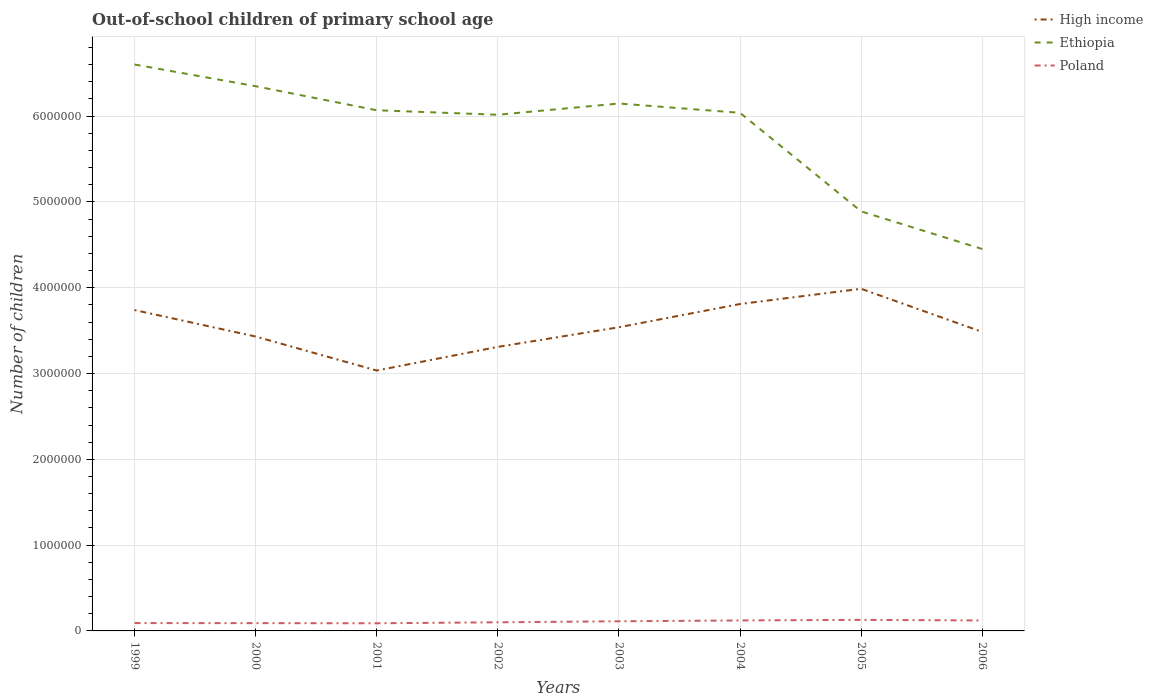How many different coloured lines are there?
Keep it short and to the point. 3. Across all years, what is the maximum number of out-of-school children in High income?
Offer a very short reply. 3.03e+06. In which year was the number of out-of-school children in Poland maximum?
Offer a terse response. 2001. What is the total number of out-of-school children in High income in the graph?
Ensure brevity in your answer.  4.29e+05. What is the difference between the highest and the second highest number of out-of-school children in Ethiopia?
Keep it short and to the point. 2.15e+06. What is the difference between the highest and the lowest number of out-of-school children in Poland?
Your answer should be compact. 4. Is the number of out-of-school children in Ethiopia strictly greater than the number of out-of-school children in High income over the years?
Ensure brevity in your answer.  No. How many lines are there?
Make the answer very short. 3. Are the values on the major ticks of Y-axis written in scientific E-notation?
Give a very brief answer. No. Does the graph contain any zero values?
Your answer should be very brief. No. Does the graph contain grids?
Your answer should be compact. Yes. Where does the legend appear in the graph?
Give a very brief answer. Top right. How many legend labels are there?
Your answer should be compact. 3. How are the legend labels stacked?
Ensure brevity in your answer.  Vertical. What is the title of the graph?
Make the answer very short. Out-of-school children of primary school age. Does "Mauritania" appear as one of the legend labels in the graph?
Keep it short and to the point. No. What is the label or title of the Y-axis?
Provide a short and direct response. Number of children. What is the Number of children of High income in 1999?
Ensure brevity in your answer.  3.74e+06. What is the Number of children in Ethiopia in 1999?
Ensure brevity in your answer.  6.60e+06. What is the Number of children in Poland in 1999?
Your response must be concise. 9.15e+04. What is the Number of children in High income in 2000?
Ensure brevity in your answer.  3.43e+06. What is the Number of children of Ethiopia in 2000?
Your answer should be very brief. 6.35e+06. What is the Number of children of Poland in 2000?
Make the answer very short. 9.07e+04. What is the Number of children of High income in 2001?
Offer a very short reply. 3.03e+06. What is the Number of children of Ethiopia in 2001?
Provide a succinct answer. 6.07e+06. What is the Number of children of Poland in 2001?
Give a very brief answer. 8.91e+04. What is the Number of children of High income in 2002?
Make the answer very short. 3.31e+06. What is the Number of children of Ethiopia in 2002?
Your response must be concise. 6.02e+06. What is the Number of children in Poland in 2002?
Your answer should be compact. 1.00e+05. What is the Number of children in High income in 2003?
Provide a succinct answer. 3.54e+06. What is the Number of children in Ethiopia in 2003?
Your response must be concise. 6.15e+06. What is the Number of children of Poland in 2003?
Offer a very short reply. 1.12e+05. What is the Number of children of High income in 2004?
Your answer should be very brief. 3.81e+06. What is the Number of children in Ethiopia in 2004?
Offer a terse response. 6.04e+06. What is the Number of children of Poland in 2004?
Give a very brief answer. 1.22e+05. What is the Number of children in High income in 2005?
Ensure brevity in your answer.  3.99e+06. What is the Number of children of Ethiopia in 2005?
Provide a short and direct response. 4.89e+06. What is the Number of children of Poland in 2005?
Offer a terse response. 1.29e+05. What is the Number of children in High income in 2006?
Your answer should be very brief. 3.48e+06. What is the Number of children in Ethiopia in 2006?
Your answer should be compact. 4.45e+06. What is the Number of children in Poland in 2006?
Your response must be concise. 1.22e+05. Across all years, what is the maximum Number of children of High income?
Your answer should be very brief. 3.99e+06. Across all years, what is the maximum Number of children of Ethiopia?
Provide a short and direct response. 6.60e+06. Across all years, what is the maximum Number of children in Poland?
Provide a succinct answer. 1.29e+05. Across all years, what is the minimum Number of children in High income?
Offer a terse response. 3.03e+06. Across all years, what is the minimum Number of children in Ethiopia?
Keep it short and to the point. 4.45e+06. Across all years, what is the minimum Number of children in Poland?
Offer a very short reply. 8.91e+04. What is the total Number of children of High income in the graph?
Offer a terse response. 2.83e+07. What is the total Number of children of Ethiopia in the graph?
Offer a terse response. 4.66e+07. What is the total Number of children of Poland in the graph?
Ensure brevity in your answer.  8.57e+05. What is the difference between the Number of children in High income in 1999 and that in 2000?
Provide a succinct answer. 3.09e+05. What is the difference between the Number of children of Ethiopia in 1999 and that in 2000?
Provide a short and direct response. 2.53e+05. What is the difference between the Number of children in Poland in 1999 and that in 2000?
Offer a very short reply. 838. What is the difference between the Number of children in High income in 1999 and that in 2001?
Your answer should be compact. 7.05e+05. What is the difference between the Number of children of Ethiopia in 1999 and that in 2001?
Keep it short and to the point. 5.33e+05. What is the difference between the Number of children of Poland in 1999 and that in 2001?
Your response must be concise. 2426. What is the difference between the Number of children of High income in 1999 and that in 2002?
Offer a terse response. 4.29e+05. What is the difference between the Number of children in Ethiopia in 1999 and that in 2002?
Provide a succinct answer. 5.85e+05. What is the difference between the Number of children in Poland in 1999 and that in 2002?
Give a very brief answer. -8930. What is the difference between the Number of children in High income in 1999 and that in 2003?
Ensure brevity in your answer.  2.00e+05. What is the difference between the Number of children in Ethiopia in 1999 and that in 2003?
Offer a terse response. 4.55e+05. What is the difference between the Number of children in Poland in 1999 and that in 2003?
Offer a very short reply. -2.10e+04. What is the difference between the Number of children in High income in 1999 and that in 2004?
Provide a short and direct response. -7.04e+04. What is the difference between the Number of children in Ethiopia in 1999 and that in 2004?
Make the answer very short. 5.63e+05. What is the difference between the Number of children of Poland in 1999 and that in 2004?
Ensure brevity in your answer.  -3.05e+04. What is the difference between the Number of children of High income in 1999 and that in 2005?
Provide a succinct answer. -2.48e+05. What is the difference between the Number of children of Ethiopia in 1999 and that in 2005?
Provide a succinct answer. 1.71e+06. What is the difference between the Number of children of Poland in 1999 and that in 2005?
Your response must be concise. -3.75e+04. What is the difference between the Number of children in High income in 1999 and that in 2006?
Your answer should be very brief. 2.55e+05. What is the difference between the Number of children of Ethiopia in 1999 and that in 2006?
Keep it short and to the point. 2.15e+06. What is the difference between the Number of children of Poland in 1999 and that in 2006?
Make the answer very short. -3.00e+04. What is the difference between the Number of children in High income in 2000 and that in 2001?
Provide a succinct answer. 3.97e+05. What is the difference between the Number of children in Ethiopia in 2000 and that in 2001?
Ensure brevity in your answer.  2.80e+05. What is the difference between the Number of children of Poland in 2000 and that in 2001?
Make the answer very short. 1588. What is the difference between the Number of children in High income in 2000 and that in 2002?
Ensure brevity in your answer.  1.21e+05. What is the difference between the Number of children of Ethiopia in 2000 and that in 2002?
Give a very brief answer. 3.33e+05. What is the difference between the Number of children in Poland in 2000 and that in 2002?
Your answer should be very brief. -9768. What is the difference between the Number of children in High income in 2000 and that in 2003?
Your response must be concise. -1.08e+05. What is the difference between the Number of children of Ethiopia in 2000 and that in 2003?
Ensure brevity in your answer.  2.02e+05. What is the difference between the Number of children in Poland in 2000 and that in 2003?
Your answer should be very brief. -2.18e+04. What is the difference between the Number of children of High income in 2000 and that in 2004?
Provide a short and direct response. -3.79e+05. What is the difference between the Number of children in Ethiopia in 2000 and that in 2004?
Provide a succinct answer. 3.10e+05. What is the difference between the Number of children in Poland in 2000 and that in 2004?
Provide a succinct answer. -3.13e+04. What is the difference between the Number of children of High income in 2000 and that in 2005?
Keep it short and to the point. -5.56e+05. What is the difference between the Number of children in Ethiopia in 2000 and that in 2005?
Make the answer very short. 1.46e+06. What is the difference between the Number of children of Poland in 2000 and that in 2005?
Offer a terse response. -3.83e+04. What is the difference between the Number of children in High income in 2000 and that in 2006?
Make the answer very short. -5.37e+04. What is the difference between the Number of children of Ethiopia in 2000 and that in 2006?
Provide a short and direct response. 1.90e+06. What is the difference between the Number of children of Poland in 2000 and that in 2006?
Make the answer very short. -3.09e+04. What is the difference between the Number of children of High income in 2001 and that in 2002?
Your answer should be compact. -2.76e+05. What is the difference between the Number of children of Ethiopia in 2001 and that in 2002?
Offer a very short reply. 5.23e+04. What is the difference between the Number of children in Poland in 2001 and that in 2002?
Make the answer very short. -1.14e+04. What is the difference between the Number of children in High income in 2001 and that in 2003?
Provide a succinct answer. -5.05e+05. What is the difference between the Number of children in Ethiopia in 2001 and that in 2003?
Offer a terse response. -7.86e+04. What is the difference between the Number of children in Poland in 2001 and that in 2003?
Offer a very short reply. -2.34e+04. What is the difference between the Number of children of High income in 2001 and that in 2004?
Your answer should be very brief. -7.75e+05. What is the difference between the Number of children in Ethiopia in 2001 and that in 2004?
Give a very brief answer. 2.96e+04. What is the difference between the Number of children in Poland in 2001 and that in 2004?
Offer a terse response. -3.29e+04. What is the difference between the Number of children in High income in 2001 and that in 2005?
Your answer should be very brief. -9.53e+05. What is the difference between the Number of children of Ethiopia in 2001 and that in 2005?
Give a very brief answer. 1.18e+06. What is the difference between the Number of children of Poland in 2001 and that in 2005?
Give a very brief answer. -3.99e+04. What is the difference between the Number of children in High income in 2001 and that in 2006?
Provide a short and direct response. -4.50e+05. What is the difference between the Number of children in Ethiopia in 2001 and that in 2006?
Provide a succinct answer. 1.62e+06. What is the difference between the Number of children in Poland in 2001 and that in 2006?
Make the answer very short. -3.25e+04. What is the difference between the Number of children in High income in 2002 and that in 2003?
Offer a terse response. -2.29e+05. What is the difference between the Number of children of Ethiopia in 2002 and that in 2003?
Your answer should be very brief. -1.31e+05. What is the difference between the Number of children in Poland in 2002 and that in 2003?
Offer a very short reply. -1.20e+04. What is the difference between the Number of children in High income in 2002 and that in 2004?
Your response must be concise. -5.00e+05. What is the difference between the Number of children of Ethiopia in 2002 and that in 2004?
Offer a terse response. -2.27e+04. What is the difference between the Number of children of Poland in 2002 and that in 2004?
Give a very brief answer. -2.15e+04. What is the difference between the Number of children in High income in 2002 and that in 2005?
Provide a succinct answer. -6.77e+05. What is the difference between the Number of children in Ethiopia in 2002 and that in 2005?
Your response must be concise. 1.13e+06. What is the difference between the Number of children of Poland in 2002 and that in 2005?
Offer a very short reply. -2.85e+04. What is the difference between the Number of children of High income in 2002 and that in 2006?
Your answer should be very brief. -1.74e+05. What is the difference between the Number of children of Ethiopia in 2002 and that in 2006?
Provide a short and direct response. 1.56e+06. What is the difference between the Number of children of Poland in 2002 and that in 2006?
Provide a succinct answer. -2.11e+04. What is the difference between the Number of children in High income in 2003 and that in 2004?
Provide a short and direct response. -2.71e+05. What is the difference between the Number of children in Ethiopia in 2003 and that in 2004?
Give a very brief answer. 1.08e+05. What is the difference between the Number of children of Poland in 2003 and that in 2004?
Offer a terse response. -9523. What is the difference between the Number of children of High income in 2003 and that in 2005?
Make the answer very short. -4.48e+05. What is the difference between the Number of children in Ethiopia in 2003 and that in 2005?
Offer a terse response. 1.26e+06. What is the difference between the Number of children in Poland in 2003 and that in 2005?
Your response must be concise. -1.65e+04. What is the difference between the Number of children in High income in 2003 and that in 2006?
Offer a very short reply. 5.45e+04. What is the difference between the Number of children in Ethiopia in 2003 and that in 2006?
Offer a very short reply. 1.70e+06. What is the difference between the Number of children in Poland in 2003 and that in 2006?
Provide a short and direct response. -9075. What is the difference between the Number of children of High income in 2004 and that in 2005?
Keep it short and to the point. -1.77e+05. What is the difference between the Number of children in Ethiopia in 2004 and that in 2005?
Provide a short and direct response. 1.15e+06. What is the difference between the Number of children in Poland in 2004 and that in 2005?
Your answer should be compact. -6979. What is the difference between the Number of children in High income in 2004 and that in 2006?
Your answer should be compact. 3.25e+05. What is the difference between the Number of children of Ethiopia in 2004 and that in 2006?
Your answer should be compact. 1.59e+06. What is the difference between the Number of children in Poland in 2004 and that in 2006?
Your answer should be compact. 448. What is the difference between the Number of children in High income in 2005 and that in 2006?
Your answer should be very brief. 5.03e+05. What is the difference between the Number of children in Ethiopia in 2005 and that in 2006?
Offer a very short reply. 4.39e+05. What is the difference between the Number of children of Poland in 2005 and that in 2006?
Make the answer very short. 7427. What is the difference between the Number of children of High income in 1999 and the Number of children of Ethiopia in 2000?
Offer a very short reply. -2.61e+06. What is the difference between the Number of children of High income in 1999 and the Number of children of Poland in 2000?
Keep it short and to the point. 3.65e+06. What is the difference between the Number of children in Ethiopia in 1999 and the Number of children in Poland in 2000?
Give a very brief answer. 6.51e+06. What is the difference between the Number of children in High income in 1999 and the Number of children in Ethiopia in 2001?
Your answer should be very brief. -2.33e+06. What is the difference between the Number of children of High income in 1999 and the Number of children of Poland in 2001?
Your answer should be very brief. 3.65e+06. What is the difference between the Number of children of Ethiopia in 1999 and the Number of children of Poland in 2001?
Provide a succinct answer. 6.51e+06. What is the difference between the Number of children of High income in 1999 and the Number of children of Ethiopia in 2002?
Make the answer very short. -2.28e+06. What is the difference between the Number of children of High income in 1999 and the Number of children of Poland in 2002?
Give a very brief answer. 3.64e+06. What is the difference between the Number of children in Ethiopia in 1999 and the Number of children in Poland in 2002?
Give a very brief answer. 6.50e+06. What is the difference between the Number of children of High income in 1999 and the Number of children of Ethiopia in 2003?
Your answer should be very brief. -2.41e+06. What is the difference between the Number of children in High income in 1999 and the Number of children in Poland in 2003?
Make the answer very short. 3.63e+06. What is the difference between the Number of children of Ethiopia in 1999 and the Number of children of Poland in 2003?
Your response must be concise. 6.49e+06. What is the difference between the Number of children of High income in 1999 and the Number of children of Ethiopia in 2004?
Give a very brief answer. -2.30e+06. What is the difference between the Number of children in High income in 1999 and the Number of children in Poland in 2004?
Your answer should be compact. 3.62e+06. What is the difference between the Number of children in Ethiopia in 1999 and the Number of children in Poland in 2004?
Offer a very short reply. 6.48e+06. What is the difference between the Number of children in High income in 1999 and the Number of children in Ethiopia in 2005?
Ensure brevity in your answer.  -1.15e+06. What is the difference between the Number of children of High income in 1999 and the Number of children of Poland in 2005?
Your response must be concise. 3.61e+06. What is the difference between the Number of children of Ethiopia in 1999 and the Number of children of Poland in 2005?
Offer a terse response. 6.47e+06. What is the difference between the Number of children in High income in 1999 and the Number of children in Ethiopia in 2006?
Provide a short and direct response. -7.11e+05. What is the difference between the Number of children in High income in 1999 and the Number of children in Poland in 2006?
Keep it short and to the point. 3.62e+06. What is the difference between the Number of children in Ethiopia in 1999 and the Number of children in Poland in 2006?
Give a very brief answer. 6.48e+06. What is the difference between the Number of children of High income in 2000 and the Number of children of Ethiopia in 2001?
Offer a very short reply. -2.64e+06. What is the difference between the Number of children of High income in 2000 and the Number of children of Poland in 2001?
Offer a very short reply. 3.34e+06. What is the difference between the Number of children in Ethiopia in 2000 and the Number of children in Poland in 2001?
Your answer should be very brief. 6.26e+06. What is the difference between the Number of children of High income in 2000 and the Number of children of Ethiopia in 2002?
Ensure brevity in your answer.  -2.58e+06. What is the difference between the Number of children in High income in 2000 and the Number of children in Poland in 2002?
Provide a short and direct response. 3.33e+06. What is the difference between the Number of children in Ethiopia in 2000 and the Number of children in Poland in 2002?
Offer a terse response. 6.25e+06. What is the difference between the Number of children in High income in 2000 and the Number of children in Ethiopia in 2003?
Offer a terse response. -2.72e+06. What is the difference between the Number of children in High income in 2000 and the Number of children in Poland in 2003?
Make the answer very short. 3.32e+06. What is the difference between the Number of children of Ethiopia in 2000 and the Number of children of Poland in 2003?
Your answer should be very brief. 6.24e+06. What is the difference between the Number of children in High income in 2000 and the Number of children in Ethiopia in 2004?
Offer a very short reply. -2.61e+06. What is the difference between the Number of children of High income in 2000 and the Number of children of Poland in 2004?
Keep it short and to the point. 3.31e+06. What is the difference between the Number of children in Ethiopia in 2000 and the Number of children in Poland in 2004?
Make the answer very short. 6.23e+06. What is the difference between the Number of children of High income in 2000 and the Number of children of Ethiopia in 2005?
Provide a succinct answer. -1.46e+06. What is the difference between the Number of children of High income in 2000 and the Number of children of Poland in 2005?
Make the answer very short. 3.30e+06. What is the difference between the Number of children of Ethiopia in 2000 and the Number of children of Poland in 2005?
Your response must be concise. 6.22e+06. What is the difference between the Number of children of High income in 2000 and the Number of children of Ethiopia in 2006?
Ensure brevity in your answer.  -1.02e+06. What is the difference between the Number of children in High income in 2000 and the Number of children in Poland in 2006?
Your answer should be very brief. 3.31e+06. What is the difference between the Number of children of Ethiopia in 2000 and the Number of children of Poland in 2006?
Ensure brevity in your answer.  6.23e+06. What is the difference between the Number of children of High income in 2001 and the Number of children of Ethiopia in 2002?
Keep it short and to the point. -2.98e+06. What is the difference between the Number of children of High income in 2001 and the Number of children of Poland in 2002?
Offer a terse response. 2.93e+06. What is the difference between the Number of children in Ethiopia in 2001 and the Number of children in Poland in 2002?
Keep it short and to the point. 5.97e+06. What is the difference between the Number of children of High income in 2001 and the Number of children of Ethiopia in 2003?
Keep it short and to the point. -3.11e+06. What is the difference between the Number of children in High income in 2001 and the Number of children in Poland in 2003?
Make the answer very short. 2.92e+06. What is the difference between the Number of children of Ethiopia in 2001 and the Number of children of Poland in 2003?
Provide a succinct answer. 5.96e+06. What is the difference between the Number of children in High income in 2001 and the Number of children in Ethiopia in 2004?
Your answer should be compact. -3.00e+06. What is the difference between the Number of children in High income in 2001 and the Number of children in Poland in 2004?
Your answer should be very brief. 2.91e+06. What is the difference between the Number of children of Ethiopia in 2001 and the Number of children of Poland in 2004?
Your response must be concise. 5.95e+06. What is the difference between the Number of children of High income in 2001 and the Number of children of Ethiopia in 2005?
Provide a succinct answer. -1.86e+06. What is the difference between the Number of children of High income in 2001 and the Number of children of Poland in 2005?
Your response must be concise. 2.91e+06. What is the difference between the Number of children of Ethiopia in 2001 and the Number of children of Poland in 2005?
Provide a succinct answer. 5.94e+06. What is the difference between the Number of children in High income in 2001 and the Number of children in Ethiopia in 2006?
Your response must be concise. -1.42e+06. What is the difference between the Number of children in High income in 2001 and the Number of children in Poland in 2006?
Your answer should be very brief. 2.91e+06. What is the difference between the Number of children in Ethiopia in 2001 and the Number of children in Poland in 2006?
Offer a terse response. 5.95e+06. What is the difference between the Number of children in High income in 2002 and the Number of children in Ethiopia in 2003?
Offer a very short reply. -2.84e+06. What is the difference between the Number of children of High income in 2002 and the Number of children of Poland in 2003?
Give a very brief answer. 3.20e+06. What is the difference between the Number of children of Ethiopia in 2002 and the Number of children of Poland in 2003?
Ensure brevity in your answer.  5.90e+06. What is the difference between the Number of children in High income in 2002 and the Number of children in Ethiopia in 2004?
Your response must be concise. -2.73e+06. What is the difference between the Number of children in High income in 2002 and the Number of children in Poland in 2004?
Ensure brevity in your answer.  3.19e+06. What is the difference between the Number of children in Ethiopia in 2002 and the Number of children in Poland in 2004?
Give a very brief answer. 5.89e+06. What is the difference between the Number of children of High income in 2002 and the Number of children of Ethiopia in 2005?
Make the answer very short. -1.58e+06. What is the difference between the Number of children in High income in 2002 and the Number of children in Poland in 2005?
Give a very brief answer. 3.18e+06. What is the difference between the Number of children in Ethiopia in 2002 and the Number of children in Poland in 2005?
Ensure brevity in your answer.  5.89e+06. What is the difference between the Number of children of High income in 2002 and the Number of children of Ethiopia in 2006?
Make the answer very short. -1.14e+06. What is the difference between the Number of children of High income in 2002 and the Number of children of Poland in 2006?
Your answer should be compact. 3.19e+06. What is the difference between the Number of children of Ethiopia in 2002 and the Number of children of Poland in 2006?
Keep it short and to the point. 5.89e+06. What is the difference between the Number of children of High income in 2003 and the Number of children of Ethiopia in 2004?
Give a very brief answer. -2.50e+06. What is the difference between the Number of children in High income in 2003 and the Number of children in Poland in 2004?
Your response must be concise. 3.42e+06. What is the difference between the Number of children in Ethiopia in 2003 and the Number of children in Poland in 2004?
Your answer should be very brief. 6.03e+06. What is the difference between the Number of children of High income in 2003 and the Number of children of Ethiopia in 2005?
Keep it short and to the point. -1.35e+06. What is the difference between the Number of children in High income in 2003 and the Number of children in Poland in 2005?
Your answer should be very brief. 3.41e+06. What is the difference between the Number of children of Ethiopia in 2003 and the Number of children of Poland in 2005?
Make the answer very short. 6.02e+06. What is the difference between the Number of children in High income in 2003 and the Number of children in Ethiopia in 2006?
Make the answer very short. -9.12e+05. What is the difference between the Number of children in High income in 2003 and the Number of children in Poland in 2006?
Offer a terse response. 3.42e+06. What is the difference between the Number of children in Ethiopia in 2003 and the Number of children in Poland in 2006?
Your answer should be very brief. 6.03e+06. What is the difference between the Number of children of High income in 2004 and the Number of children of Ethiopia in 2005?
Keep it short and to the point. -1.08e+06. What is the difference between the Number of children in High income in 2004 and the Number of children in Poland in 2005?
Make the answer very short. 3.68e+06. What is the difference between the Number of children of Ethiopia in 2004 and the Number of children of Poland in 2005?
Provide a short and direct response. 5.91e+06. What is the difference between the Number of children in High income in 2004 and the Number of children in Ethiopia in 2006?
Your response must be concise. -6.41e+05. What is the difference between the Number of children of High income in 2004 and the Number of children of Poland in 2006?
Your answer should be very brief. 3.69e+06. What is the difference between the Number of children of Ethiopia in 2004 and the Number of children of Poland in 2006?
Your response must be concise. 5.92e+06. What is the difference between the Number of children of High income in 2005 and the Number of children of Ethiopia in 2006?
Provide a succinct answer. -4.64e+05. What is the difference between the Number of children of High income in 2005 and the Number of children of Poland in 2006?
Provide a succinct answer. 3.87e+06. What is the difference between the Number of children of Ethiopia in 2005 and the Number of children of Poland in 2006?
Make the answer very short. 4.77e+06. What is the average Number of children of High income per year?
Your answer should be very brief. 3.54e+06. What is the average Number of children in Ethiopia per year?
Provide a short and direct response. 5.82e+06. What is the average Number of children of Poland per year?
Your response must be concise. 1.07e+05. In the year 1999, what is the difference between the Number of children in High income and Number of children in Ethiopia?
Offer a very short reply. -2.86e+06. In the year 1999, what is the difference between the Number of children in High income and Number of children in Poland?
Your answer should be compact. 3.65e+06. In the year 1999, what is the difference between the Number of children of Ethiopia and Number of children of Poland?
Provide a succinct answer. 6.51e+06. In the year 2000, what is the difference between the Number of children of High income and Number of children of Ethiopia?
Your answer should be compact. -2.92e+06. In the year 2000, what is the difference between the Number of children of High income and Number of children of Poland?
Your answer should be very brief. 3.34e+06. In the year 2000, what is the difference between the Number of children in Ethiopia and Number of children in Poland?
Your response must be concise. 6.26e+06. In the year 2001, what is the difference between the Number of children in High income and Number of children in Ethiopia?
Offer a terse response. -3.03e+06. In the year 2001, what is the difference between the Number of children of High income and Number of children of Poland?
Your answer should be compact. 2.95e+06. In the year 2001, what is the difference between the Number of children in Ethiopia and Number of children in Poland?
Make the answer very short. 5.98e+06. In the year 2002, what is the difference between the Number of children in High income and Number of children in Ethiopia?
Your answer should be very brief. -2.71e+06. In the year 2002, what is the difference between the Number of children in High income and Number of children in Poland?
Provide a short and direct response. 3.21e+06. In the year 2002, what is the difference between the Number of children in Ethiopia and Number of children in Poland?
Ensure brevity in your answer.  5.92e+06. In the year 2003, what is the difference between the Number of children of High income and Number of children of Ethiopia?
Make the answer very short. -2.61e+06. In the year 2003, what is the difference between the Number of children in High income and Number of children in Poland?
Ensure brevity in your answer.  3.43e+06. In the year 2003, what is the difference between the Number of children of Ethiopia and Number of children of Poland?
Offer a terse response. 6.03e+06. In the year 2004, what is the difference between the Number of children of High income and Number of children of Ethiopia?
Make the answer very short. -2.23e+06. In the year 2004, what is the difference between the Number of children of High income and Number of children of Poland?
Provide a short and direct response. 3.69e+06. In the year 2004, what is the difference between the Number of children of Ethiopia and Number of children of Poland?
Provide a short and direct response. 5.92e+06. In the year 2005, what is the difference between the Number of children of High income and Number of children of Ethiopia?
Provide a short and direct response. -9.02e+05. In the year 2005, what is the difference between the Number of children of High income and Number of children of Poland?
Offer a very short reply. 3.86e+06. In the year 2005, what is the difference between the Number of children in Ethiopia and Number of children in Poland?
Your answer should be very brief. 4.76e+06. In the year 2006, what is the difference between the Number of children in High income and Number of children in Ethiopia?
Your response must be concise. -9.66e+05. In the year 2006, what is the difference between the Number of children of High income and Number of children of Poland?
Keep it short and to the point. 3.36e+06. In the year 2006, what is the difference between the Number of children of Ethiopia and Number of children of Poland?
Keep it short and to the point. 4.33e+06. What is the ratio of the Number of children of High income in 1999 to that in 2000?
Offer a very short reply. 1.09. What is the ratio of the Number of children in Ethiopia in 1999 to that in 2000?
Give a very brief answer. 1.04. What is the ratio of the Number of children of Poland in 1999 to that in 2000?
Your response must be concise. 1.01. What is the ratio of the Number of children in High income in 1999 to that in 2001?
Your answer should be very brief. 1.23. What is the ratio of the Number of children in Ethiopia in 1999 to that in 2001?
Your answer should be very brief. 1.09. What is the ratio of the Number of children in Poland in 1999 to that in 2001?
Your answer should be compact. 1.03. What is the ratio of the Number of children of High income in 1999 to that in 2002?
Your response must be concise. 1.13. What is the ratio of the Number of children of Ethiopia in 1999 to that in 2002?
Ensure brevity in your answer.  1.1. What is the ratio of the Number of children in Poland in 1999 to that in 2002?
Give a very brief answer. 0.91. What is the ratio of the Number of children in High income in 1999 to that in 2003?
Provide a short and direct response. 1.06. What is the ratio of the Number of children of Ethiopia in 1999 to that in 2003?
Provide a short and direct response. 1.07. What is the ratio of the Number of children in Poland in 1999 to that in 2003?
Your answer should be very brief. 0.81. What is the ratio of the Number of children of High income in 1999 to that in 2004?
Your response must be concise. 0.98. What is the ratio of the Number of children in Ethiopia in 1999 to that in 2004?
Offer a terse response. 1.09. What is the ratio of the Number of children of Poland in 1999 to that in 2004?
Your response must be concise. 0.75. What is the ratio of the Number of children of High income in 1999 to that in 2005?
Ensure brevity in your answer.  0.94. What is the ratio of the Number of children of Ethiopia in 1999 to that in 2005?
Your response must be concise. 1.35. What is the ratio of the Number of children of Poland in 1999 to that in 2005?
Keep it short and to the point. 0.71. What is the ratio of the Number of children in High income in 1999 to that in 2006?
Offer a very short reply. 1.07. What is the ratio of the Number of children of Ethiopia in 1999 to that in 2006?
Offer a terse response. 1.48. What is the ratio of the Number of children of Poland in 1999 to that in 2006?
Your answer should be compact. 0.75. What is the ratio of the Number of children in High income in 2000 to that in 2001?
Ensure brevity in your answer.  1.13. What is the ratio of the Number of children in Ethiopia in 2000 to that in 2001?
Your answer should be compact. 1.05. What is the ratio of the Number of children of Poland in 2000 to that in 2001?
Offer a very short reply. 1.02. What is the ratio of the Number of children in High income in 2000 to that in 2002?
Your response must be concise. 1.04. What is the ratio of the Number of children of Ethiopia in 2000 to that in 2002?
Ensure brevity in your answer.  1.06. What is the ratio of the Number of children in Poland in 2000 to that in 2002?
Offer a very short reply. 0.9. What is the ratio of the Number of children of High income in 2000 to that in 2003?
Your answer should be compact. 0.97. What is the ratio of the Number of children of Ethiopia in 2000 to that in 2003?
Your answer should be very brief. 1.03. What is the ratio of the Number of children of Poland in 2000 to that in 2003?
Offer a terse response. 0.81. What is the ratio of the Number of children of High income in 2000 to that in 2004?
Offer a terse response. 0.9. What is the ratio of the Number of children of Ethiopia in 2000 to that in 2004?
Provide a succinct answer. 1.05. What is the ratio of the Number of children of Poland in 2000 to that in 2004?
Your response must be concise. 0.74. What is the ratio of the Number of children in High income in 2000 to that in 2005?
Keep it short and to the point. 0.86. What is the ratio of the Number of children in Ethiopia in 2000 to that in 2005?
Your answer should be compact. 1.3. What is the ratio of the Number of children in Poland in 2000 to that in 2005?
Make the answer very short. 0.7. What is the ratio of the Number of children of High income in 2000 to that in 2006?
Your answer should be compact. 0.98. What is the ratio of the Number of children of Ethiopia in 2000 to that in 2006?
Your answer should be compact. 1.43. What is the ratio of the Number of children of Poland in 2000 to that in 2006?
Keep it short and to the point. 0.75. What is the ratio of the Number of children in High income in 2001 to that in 2002?
Provide a short and direct response. 0.92. What is the ratio of the Number of children in Ethiopia in 2001 to that in 2002?
Make the answer very short. 1.01. What is the ratio of the Number of children of Poland in 2001 to that in 2002?
Offer a terse response. 0.89. What is the ratio of the Number of children of High income in 2001 to that in 2003?
Your answer should be compact. 0.86. What is the ratio of the Number of children in Ethiopia in 2001 to that in 2003?
Your answer should be very brief. 0.99. What is the ratio of the Number of children of Poland in 2001 to that in 2003?
Provide a short and direct response. 0.79. What is the ratio of the Number of children in High income in 2001 to that in 2004?
Keep it short and to the point. 0.8. What is the ratio of the Number of children in Ethiopia in 2001 to that in 2004?
Make the answer very short. 1. What is the ratio of the Number of children in Poland in 2001 to that in 2004?
Offer a terse response. 0.73. What is the ratio of the Number of children in High income in 2001 to that in 2005?
Make the answer very short. 0.76. What is the ratio of the Number of children in Ethiopia in 2001 to that in 2005?
Your answer should be very brief. 1.24. What is the ratio of the Number of children in Poland in 2001 to that in 2005?
Offer a terse response. 0.69. What is the ratio of the Number of children of High income in 2001 to that in 2006?
Your answer should be very brief. 0.87. What is the ratio of the Number of children in Ethiopia in 2001 to that in 2006?
Ensure brevity in your answer.  1.36. What is the ratio of the Number of children of Poland in 2001 to that in 2006?
Offer a very short reply. 0.73. What is the ratio of the Number of children of High income in 2002 to that in 2003?
Ensure brevity in your answer.  0.94. What is the ratio of the Number of children of Ethiopia in 2002 to that in 2003?
Offer a terse response. 0.98. What is the ratio of the Number of children in Poland in 2002 to that in 2003?
Give a very brief answer. 0.89. What is the ratio of the Number of children of High income in 2002 to that in 2004?
Offer a terse response. 0.87. What is the ratio of the Number of children in Poland in 2002 to that in 2004?
Your response must be concise. 0.82. What is the ratio of the Number of children in High income in 2002 to that in 2005?
Offer a terse response. 0.83. What is the ratio of the Number of children in Ethiopia in 2002 to that in 2005?
Ensure brevity in your answer.  1.23. What is the ratio of the Number of children in Poland in 2002 to that in 2005?
Provide a succinct answer. 0.78. What is the ratio of the Number of children in High income in 2002 to that in 2006?
Your answer should be compact. 0.95. What is the ratio of the Number of children of Ethiopia in 2002 to that in 2006?
Offer a very short reply. 1.35. What is the ratio of the Number of children in Poland in 2002 to that in 2006?
Keep it short and to the point. 0.83. What is the ratio of the Number of children of High income in 2003 to that in 2004?
Your response must be concise. 0.93. What is the ratio of the Number of children of Ethiopia in 2003 to that in 2004?
Your response must be concise. 1.02. What is the ratio of the Number of children of Poland in 2003 to that in 2004?
Provide a short and direct response. 0.92. What is the ratio of the Number of children in High income in 2003 to that in 2005?
Ensure brevity in your answer.  0.89. What is the ratio of the Number of children of Ethiopia in 2003 to that in 2005?
Your answer should be very brief. 1.26. What is the ratio of the Number of children of Poland in 2003 to that in 2005?
Give a very brief answer. 0.87. What is the ratio of the Number of children of High income in 2003 to that in 2006?
Give a very brief answer. 1.02. What is the ratio of the Number of children in Ethiopia in 2003 to that in 2006?
Ensure brevity in your answer.  1.38. What is the ratio of the Number of children in Poland in 2003 to that in 2006?
Your answer should be very brief. 0.93. What is the ratio of the Number of children in High income in 2004 to that in 2005?
Your response must be concise. 0.96. What is the ratio of the Number of children of Ethiopia in 2004 to that in 2005?
Keep it short and to the point. 1.24. What is the ratio of the Number of children of Poland in 2004 to that in 2005?
Provide a short and direct response. 0.95. What is the ratio of the Number of children in High income in 2004 to that in 2006?
Provide a short and direct response. 1.09. What is the ratio of the Number of children of Ethiopia in 2004 to that in 2006?
Provide a short and direct response. 1.36. What is the ratio of the Number of children of Poland in 2004 to that in 2006?
Make the answer very short. 1. What is the ratio of the Number of children of High income in 2005 to that in 2006?
Ensure brevity in your answer.  1.14. What is the ratio of the Number of children in Ethiopia in 2005 to that in 2006?
Give a very brief answer. 1.1. What is the ratio of the Number of children of Poland in 2005 to that in 2006?
Provide a short and direct response. 1.06. What is the difference between the highest and the second highest Number of children of High income?
Provide a short and direct response. 1.77e+05. What is the difference between the highest and the second highest Number of children in Ethiopia?
Provide a short and direct response. 2.53e+05. What is the difference between the highest and the second highest Number of children of Poland?
Offer a very short reply. 6979. What is the difference between the highest and the lowest Number of children in High income?
Provide a succinct answer. 9.53e+05. What is the difference between the highest and the lowest Number of children in Ethiopia?
Offer a terse response. 2.15e+06. What is the difference between the highest and the lowest Number of children of Poland?
Give a very brief answer. 3.99e+04. 